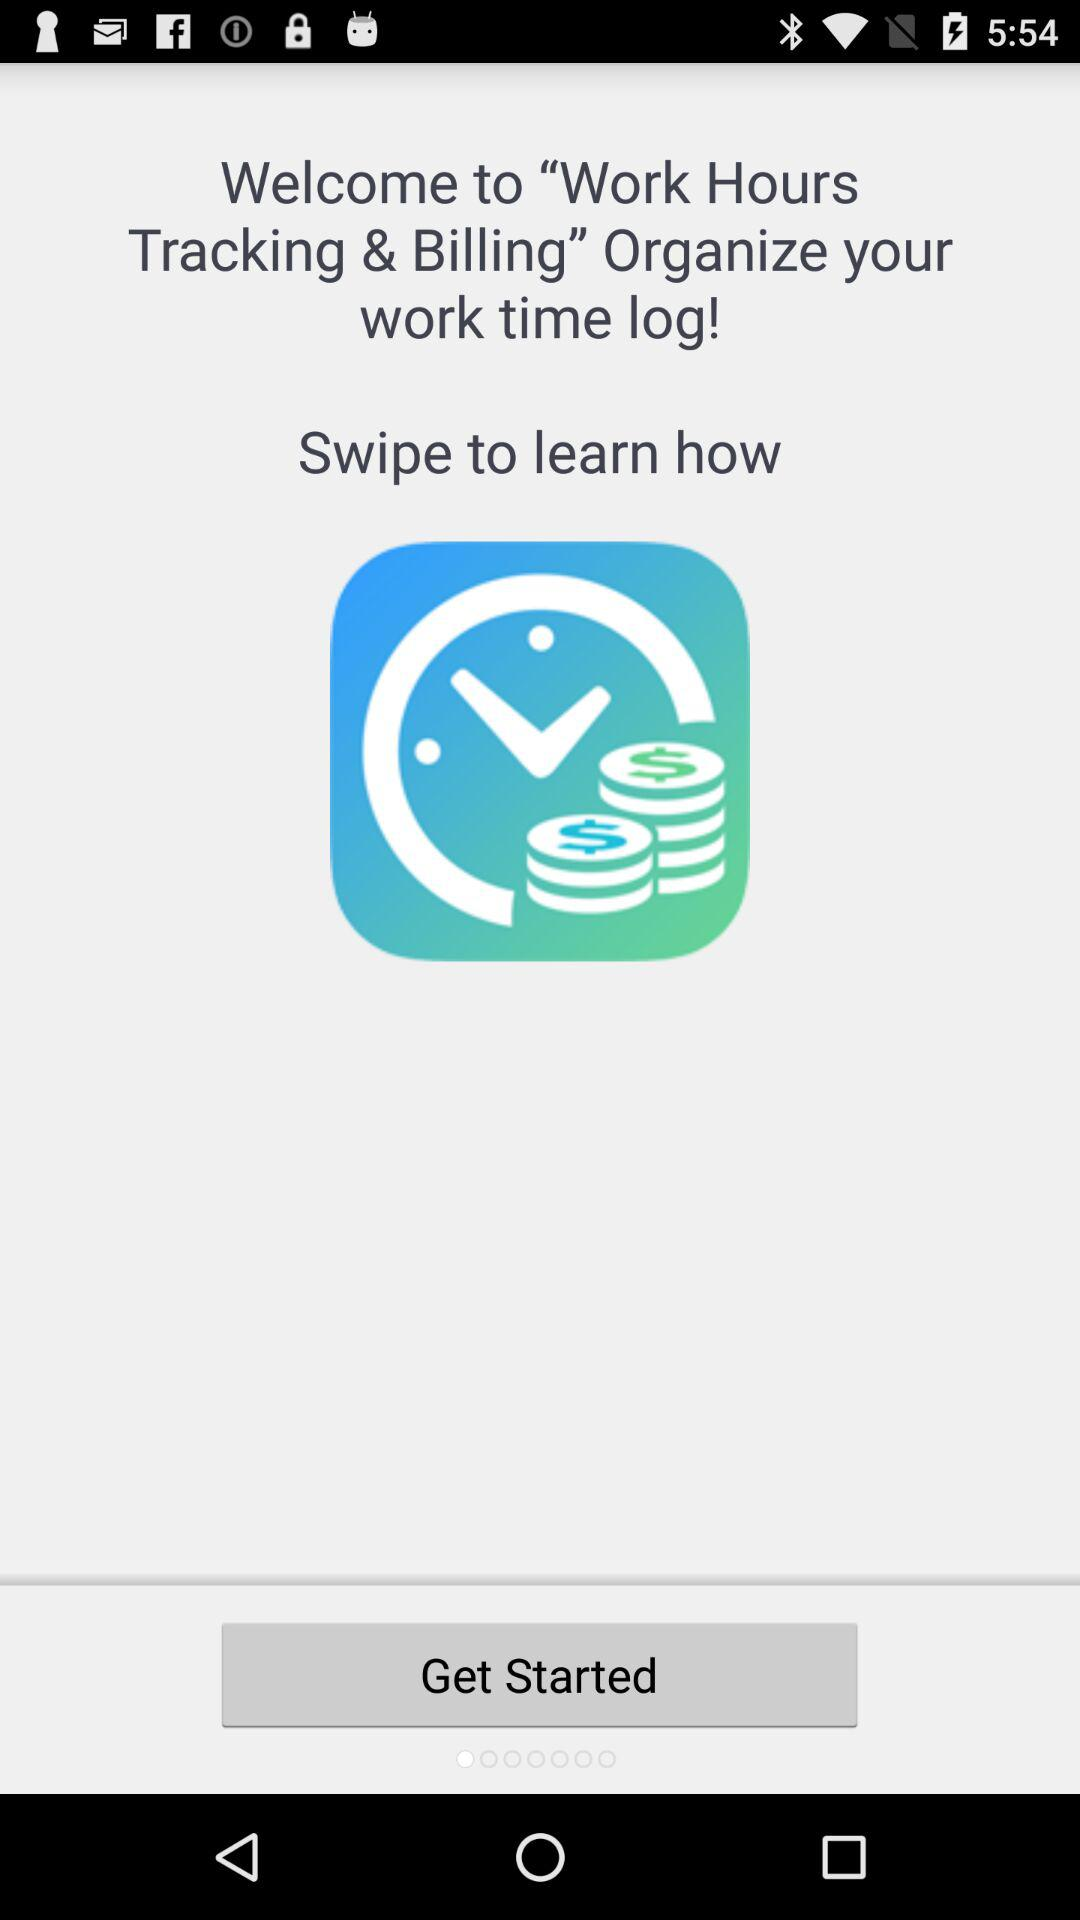What is the application name? The application name is "Work Hours Tracking & Billing". 